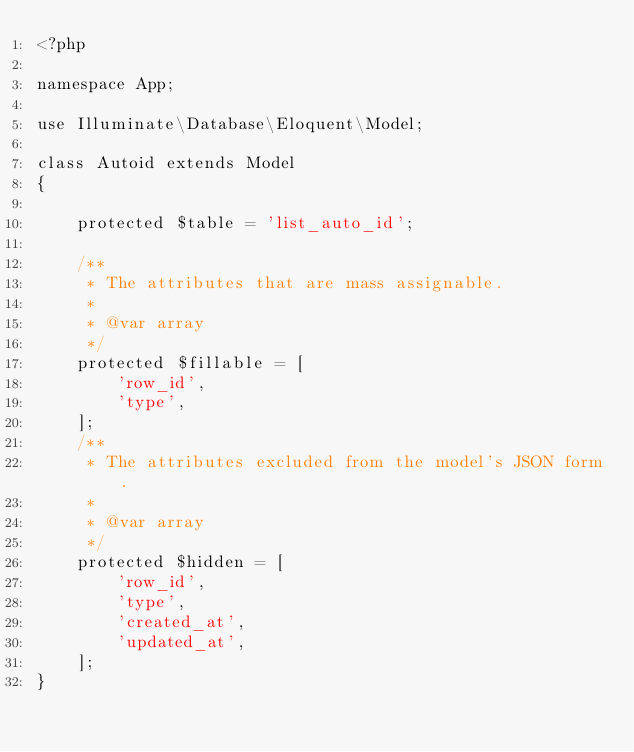Convert code to text. <code><loc_0><loc_0><loc_500><loc_500><_PHP_><?php

namespace App;

use Illuminate\Database\Eloquent\Model;

class Autoid extends Model
{
    
    protected $table = 'list_auto_id';
    
    /**
     * The attributes that are mass assignable.
     *
     * @var array
     */
    protected $fillable = [
        'row_id',
        'type',
    ];
    /**
     * The attributes excluded from the model's JSON form.
     *
     * @var array
     */
    protected $hidden = [
        'row_id',
        'type',
        'created_at',
        'updated_at',
    ];
}
</code> 